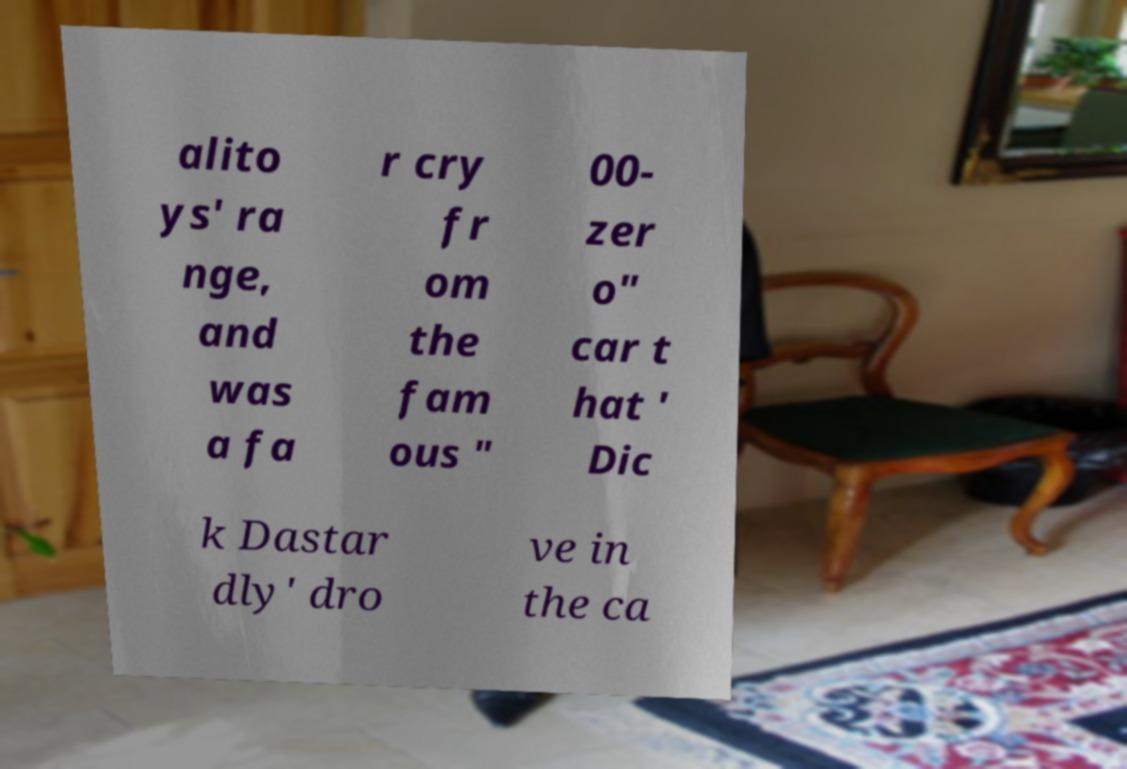Can you accurately transcribe the text from the provided image for me? alito ys' ra nge, and was a fa r cry fr om the fam ous " 00- zer o" car t hat ' Dic k Dastar dly' dro ve in the ca 